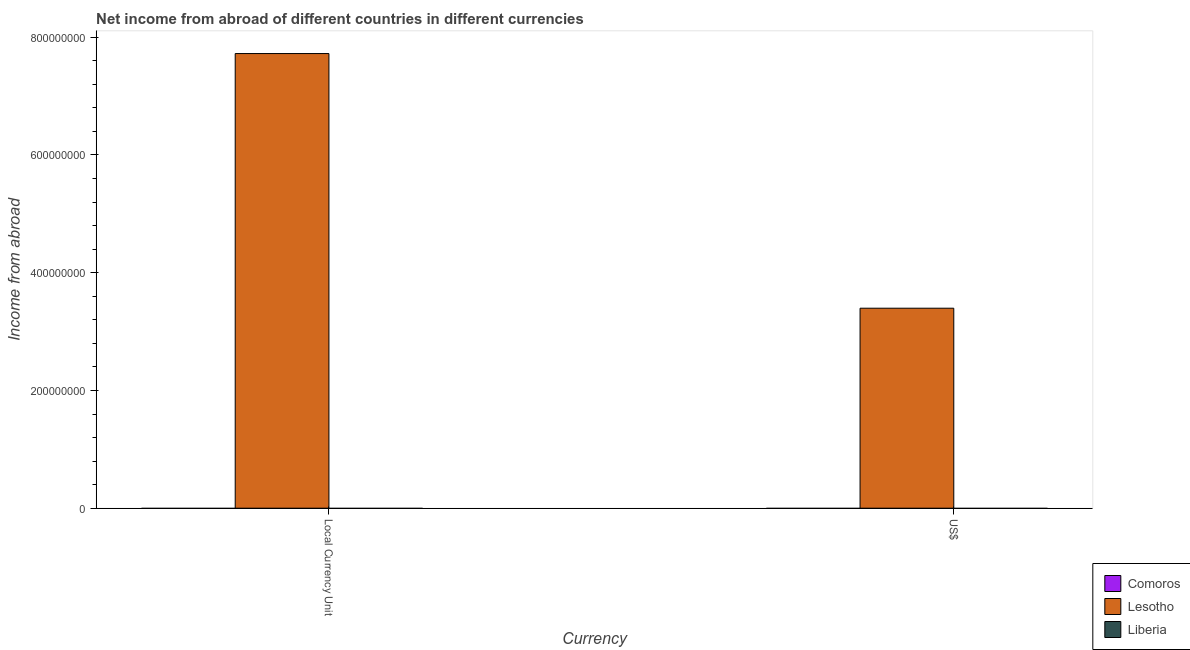How many different coloured bars are there?
Your response must be concise. 1. What is the label of the 2nd group of bars from the left?
Keep it short and to the point. US$. Across all countries, what is the maximum income from abroad in constant 2005 us$?
Give a very brief answer. 7.72e+08. Across all countries, what is the minimum income from abroad in us$?
Your answer should be very brief. 0. In which country was the income from abroad in us$ maximum?
Your answer should be compact. Lesotho. What is the total income from abroad in constant 2005 us$ in the graph?
Ensure brevity in your answer.  7.72e+08. What is the difference between the income from abroad in constant 2005 us$ in Liberia and the income from abroad in us$ in Lesotho?
Your response must be concise. -3.40e+08. What is the average income from abroad in us$ per country?
Your answer should be compact. 1.13e+08. What is the difference between the income from abroad in us$ and income from abroad in constant 2005 us$ in Lesotho?
Offer a terse response. -4.33e+08. How many bars are there?
Your response must be concise. 2. Are all the bars in the graph horizontal?
Ensure brevity in your answer.  No. How many countries are there in the graph?
Provide a succinct answer. 3. What is the difference between two consecutive major ticks on the Y-axis?
Your response must be concise. 2.00e+08. Does the graph contain any zero values?
Offer a terse response. Yes. Does the graph contain grids?
Give a very brief answer. No. How are the legend labels stacked?
Your response must be concise. Vertical. What is the title of the graph?
Provide a short and direct response. Net income from abroad of different countries in different currencies. What is the label or title of the X-axis?
Your answer should be compact. Currency. What is the label or title of the Y-axis?
Give a very brief answer. Income from abroad. What is the Income from abroad of Comoros in Local Currency Unit?
Offer a very short reply. 0. What is the Income from abroad of Lesotho in Local Currency Unit?
Make the answer very short. 7.72e+08. What is the Income from abroad in Liberia in Local Currency Unit?
Your answer should be very brief. 0. What is the Income from abroad in Lesotho in US$?
Ensure brevity in your answer.  3.40e+08. What is the Income from abroad in Liberia in US$?
Offer a terse response. 0. Across all Currency, what is the maximum Income from abroad of Lesotho?
Offer a terse response. 7.72e+08. Across all Currency, what is the minimum Income from abroad of Lesotho?
Your response must be concise. 3.40e+08. What is the total Income from abroad in Lesotho in the graph?
Make the answer very short. 1.11e+09. What is the total Income from abroad in Liberia in the graph?
Ensure brevity in your answer.  0. What is the difference between the Income from abroad of Lesotho in Local Currency Unit and that in US$?
Provide a short and direct response. 4.33e+08. What is the average Income from abroad in Lesotho per Currency?
Provide a succinct answer. 5.56e+08. What is the average Income from abroad of Liberia per Currency?
Provide a succinct answer. 0. What is the ratio of the Income from abroad in Lesotho in Local Currency Unit to that in US$?
Your answer should be very brief. 2.27. What is the difference between the highest and the second highest Income from abroad of Lesotho?
Your answer should be very brief. 4.33e+08. What is the difference between the highest and the lowest Income from abroad in Lesotho?
Your answer should be very brief. 4.33e+08. 